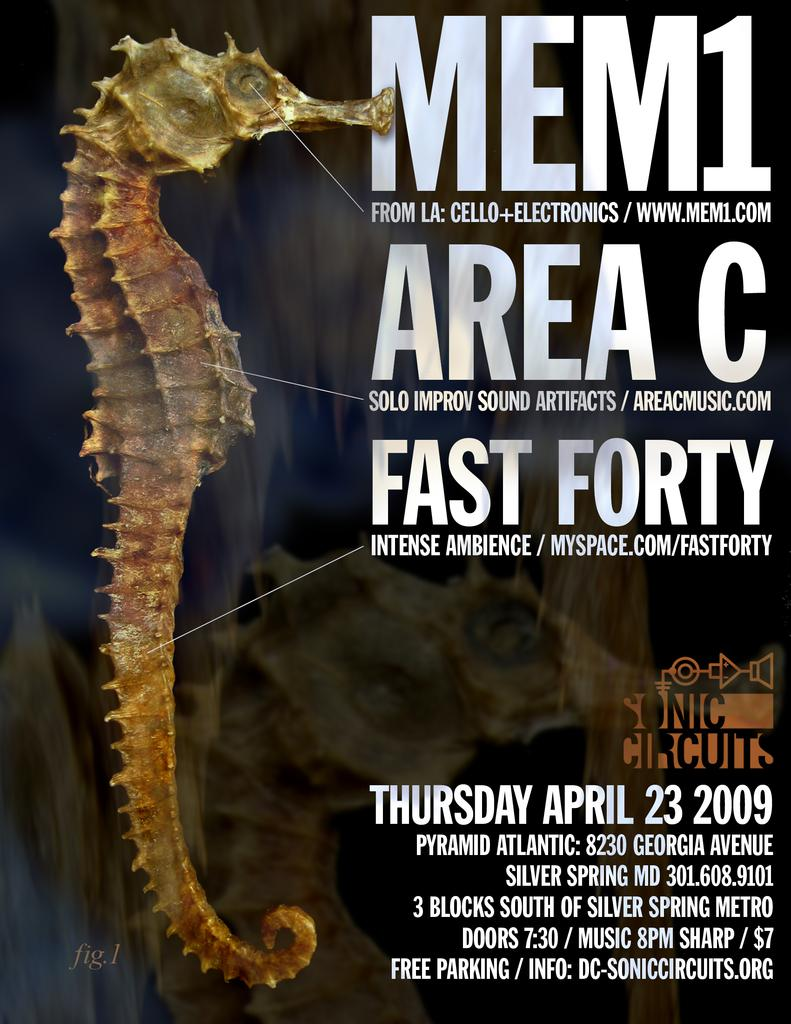What object can be seen in the picture? There is a magazine in the picture. What is the color of the magazine? The magazine is brown in color. What is depicted on the magazine? The magazine has an image of an eel. What additional information is provided alongside the image of the eel? There is some information beside the image of the eel. What type of stage is set up for the eel in the image? There is no stage present in the image; it features a magazine with an image of an eel. What kind of cable is connected to the eel in the image? There is no cable connected to the eel in the image; it is a static image on a magazine. 